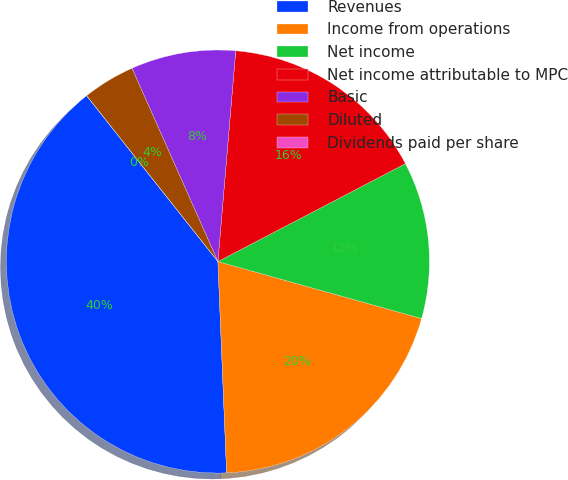Convert chart to OTSL. <chart><loc_0><loc_0><loc_500><loc_500><pie_chart><fcel>Revenues<fcel>Income from operations<fcel>Net income<fcel>Net income attributable to MPC<fcel>Basic<fcel>Diluted<fcel>Dividends paid per share<nl><fcel>40.0%<fcel>20.0%<fcel>12.0%<fcel>16.0%<fcel>8.0%<fcel>4.0%<fcel>0.0%<nl></chart> 